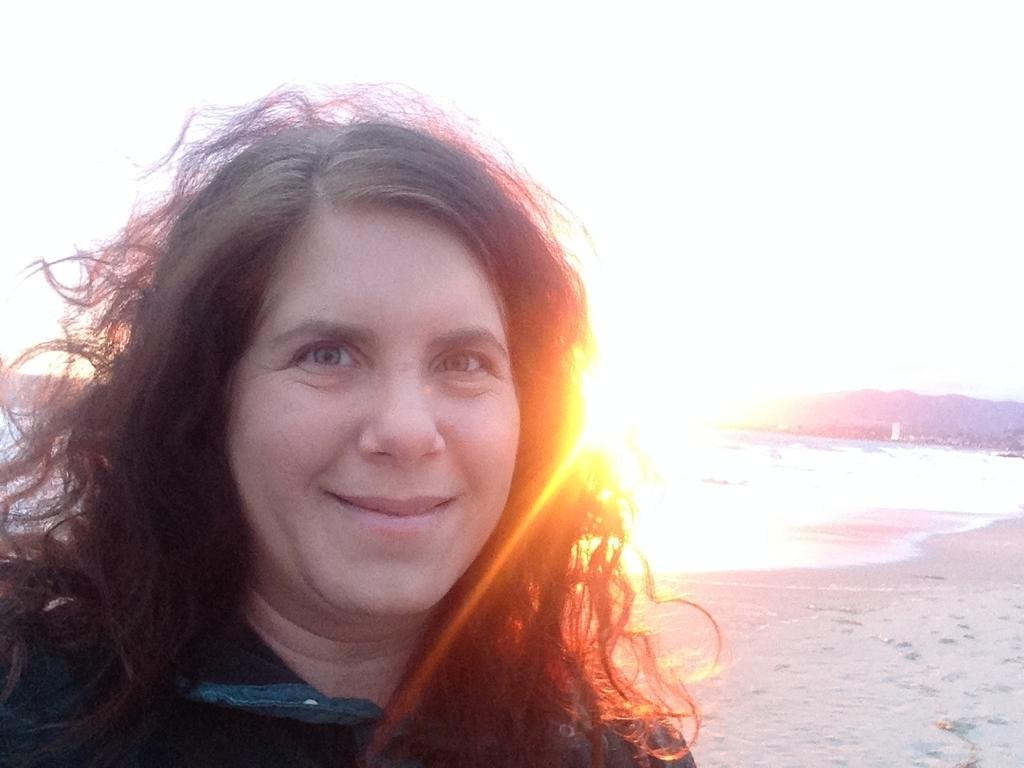Who is present in the image? There is a woman in the image. What is the woman doing in the image? The woman is smiling in the image. Where is the woman standing in the image? The woman is standing on a path in the image. What can be seen in the background of the image? Hills, water, and the sky are visible in the background of the image. What type of authority does the woman hold in the image? There is no indication of the woman holding any authority in the image. What drink is the woman holding in the image? There is no drink visible in the image. 